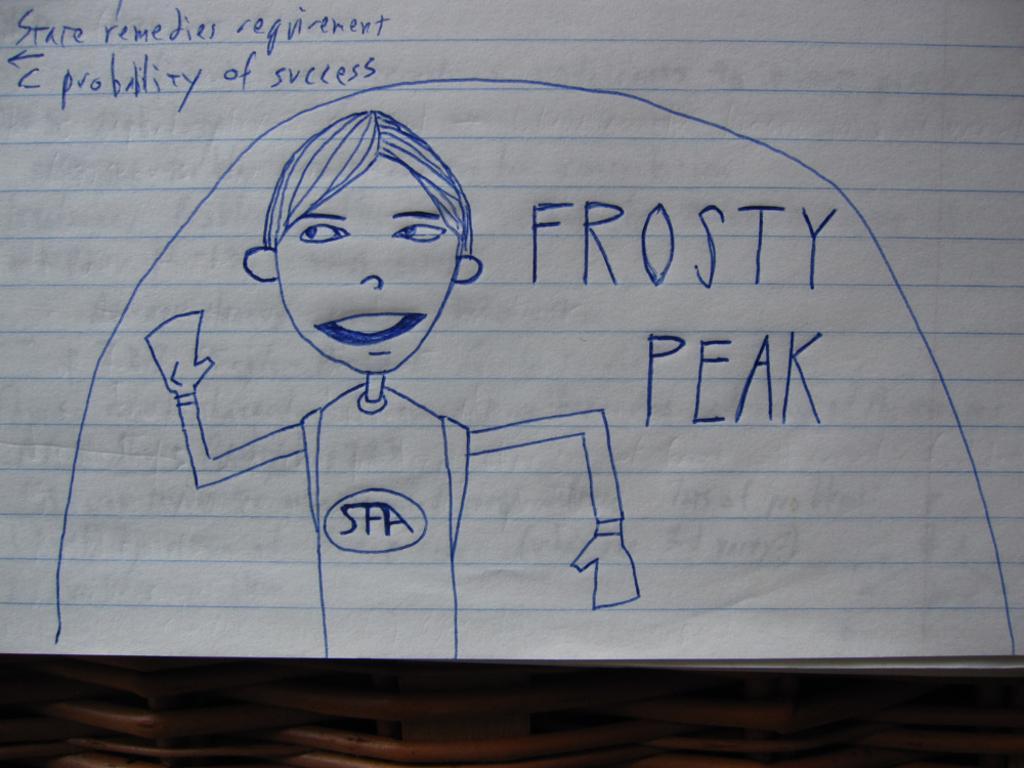How would you summarize this image in a sentence or two? This image consists of a paper on which there is a text and drawing of a boy. 